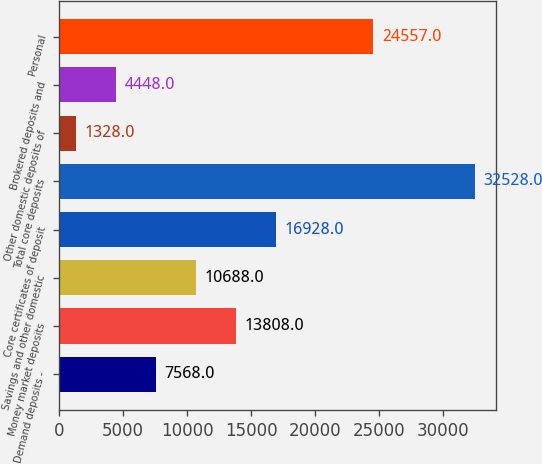Convert chart. <chart><loc_0><loc_0><loc_500><loc_500><bar_chart><fcel>Demand deposits -<fcel>Money market deposits<fcel>Savings and other domestic<fcel>Core certificates of deposit<fcel>Total core deposits<fcel>Other domestic deposits of<fcel>Brokered deposits and<fcel>Personal<nl><fcel>7568<fcel>13808<fcel>10688<fcel>16928<fcel>32528<fcel>1328<fcel>4448<fcel>24557<nl></chart> 